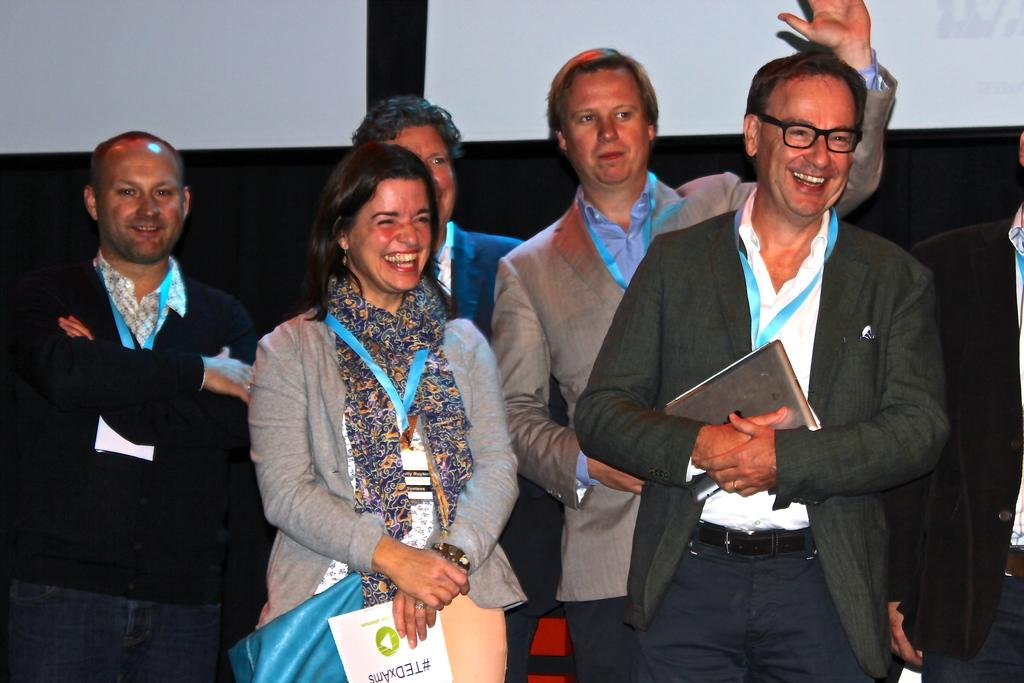How many people are present in the image? There is a group of people standing in the image, along with another person on the right side. Can you describe the positioning of the people in the image? The group of people and the person on the right side are all standing. What can be seen in the background of the image? In the background, there appear to be banners. What type of pigs are being ploughed in the image? There are no pigs or ploughs present in the image; it features a group of people and banners in the background. 